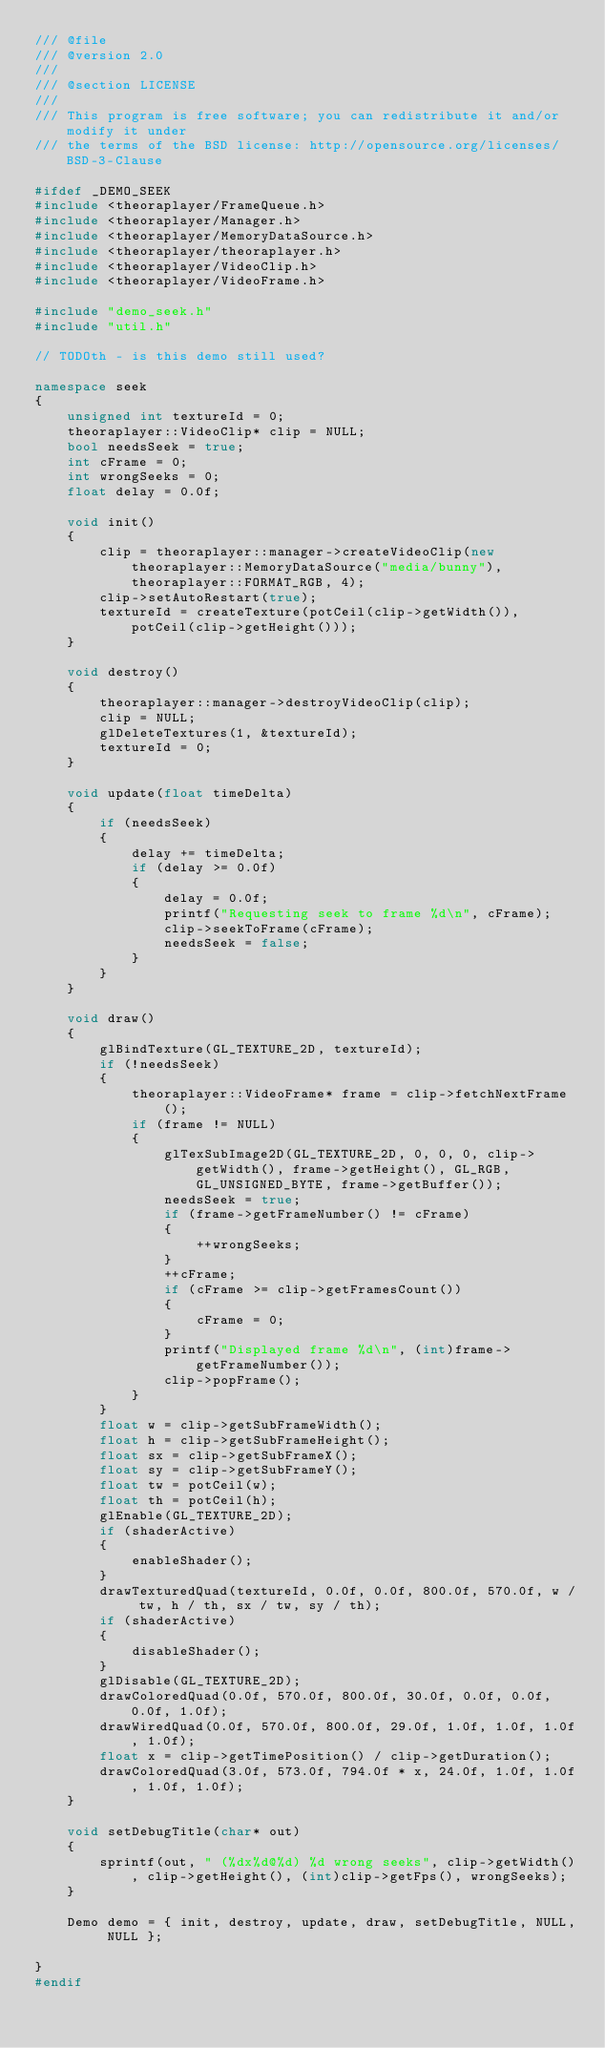Convert code to text. <code><loc_0><loc_0><loc_500><loc_500><_C++_>/// @file
/// @version 2.0
/// 
/// @section LICENSE
/// 
/// This program is free software; you can redistribute it and/or modify it under
/// the terms of the BSD license: http://opensource.org/licenses/BSD-3-Clause

#ifdef _DEMO_SEEK
#include <theoraplayer/FrameQueue.h>
#include <theoraplayer/Manager.h>
#include <theoraplayer/MemoryDataSource.h>
#include <theoraplayer/theoraplayer.h>
#include <theoraplayer/VideoClip.h>
#include <theoraplayer/VideoFrame.h>

#include "demo_seek.h"
#include "util.h"

// TODOth - is this demo still used?

namespace seek
{
	unsigned int textureId = 0;
	theoraplayer::VideoClip* clip = NULL;
	bool needsSeek = true;
	int cFrame = 0;
	int wrongSeeks = 0;
	float delay = 0.0f;

	void init()
	{
		clip = theoraplayer::manager->createVideoClip(new theoraplayer::MemoryDataSource("media/bunny"), theoraplayer::FORMAT_RGB, 4);
		clip->setAutoRestart(true);
		textureId = createTexture(potCeil(clip->getWidth()), potCeil(clip->getHeight()));
	}

	void destroy()
	{
		theoraplayer::manager->destroyVideoClip(clip);
		clip = NULL;
		glDeleteTextures(1, &textureId);
		textureId = 0;
	}

	void update(float timeDelta)
	{
		if (needsSeek)
		{
			delay += timeDelta;
			if (delay >= 0.0f)
			{
				delay = 0.0f;
				printf("Requesting seek to frame %d\n", cFrame);
				clip->seekToFrame(cFrame);
				needsSeek = false;
			}
		}
	}

	void draw()
	{
		glBindTexture(GL_TEXTURE_2D, textureId);
		if (!needsSeek)
		{
			theoraplayer::VideoFrame* frame = clip->fetchNextFrame();
			if (frame != NULL)
			{
				glTexSubImage2D(GL_TEXTURE_2D, 0, 0, 0, clip->getWidth(), frame->getHeight(), GL_RGB, GL_UNSIGNED_BYTE, frame->getBuffer());
				needsSeek = true;
				if (frame->getFrameNumber() != cFrame)
				{
					++wrongSeeks;
				}
				++cFrame;
				if (cFrame >= clip->getFramesCount())
				{
					cFrame = 0;
				}
				printf("Displayed frame %d\n", (int)frame->getFrameNumber());
				clip->popFrame();
			}
		}
		float w = clip->getSubFrameWidth();
		float h = clip->getSubFrameHeight();
		float sx = clip->getSubFrameX();
		float sy = clip->getSubFrameY();
		float tw = potCeil(w);
		float th = potCeil(h);
		glEnable(GL_TEXTURE_2D);
		if (shaderActive)
		{
			enableShader();
		}
		drawTexturedQuad(textureId, 0.0f, 0.0f, 800.0f, 570.0f, w / tw, h / th, sx / tw, sy / th);
		if (shaderActive)
		{
			disableShader();
		}
		glDisable(GL_TEXTURE_2D);
		drawColoredQuad(0.0f, 570.0f, 800.0f, 30.0f, 0.0f, 0.0f, 0.0f, 1.0f);
		drawWiredQuad(0.0f, 570.0f, 800.0f, 29.0f, 1.0f, 1.0f, 1.0f, 1.0f);
		float x = clip->getTimePosition() / clip->getDuration();
		drawColoredQuad(3.0f, 573.0f, 794.0f * x, 24.0f, 1.0f, 1.0f, 1.0f, 1.0f);
	}

	void setDebugTitle(char* out)
	{
		sprintf(out, " (%dx%d@%d) %d wrong seeks", clip->getWidth(), clip->getHeight(), (int)clip->getFps(), wrongSeeks);
	}

	Demo demo = { init, destroy, update, draw, setDebugTitle, NULL, NULL };

}
#endif
</code> 